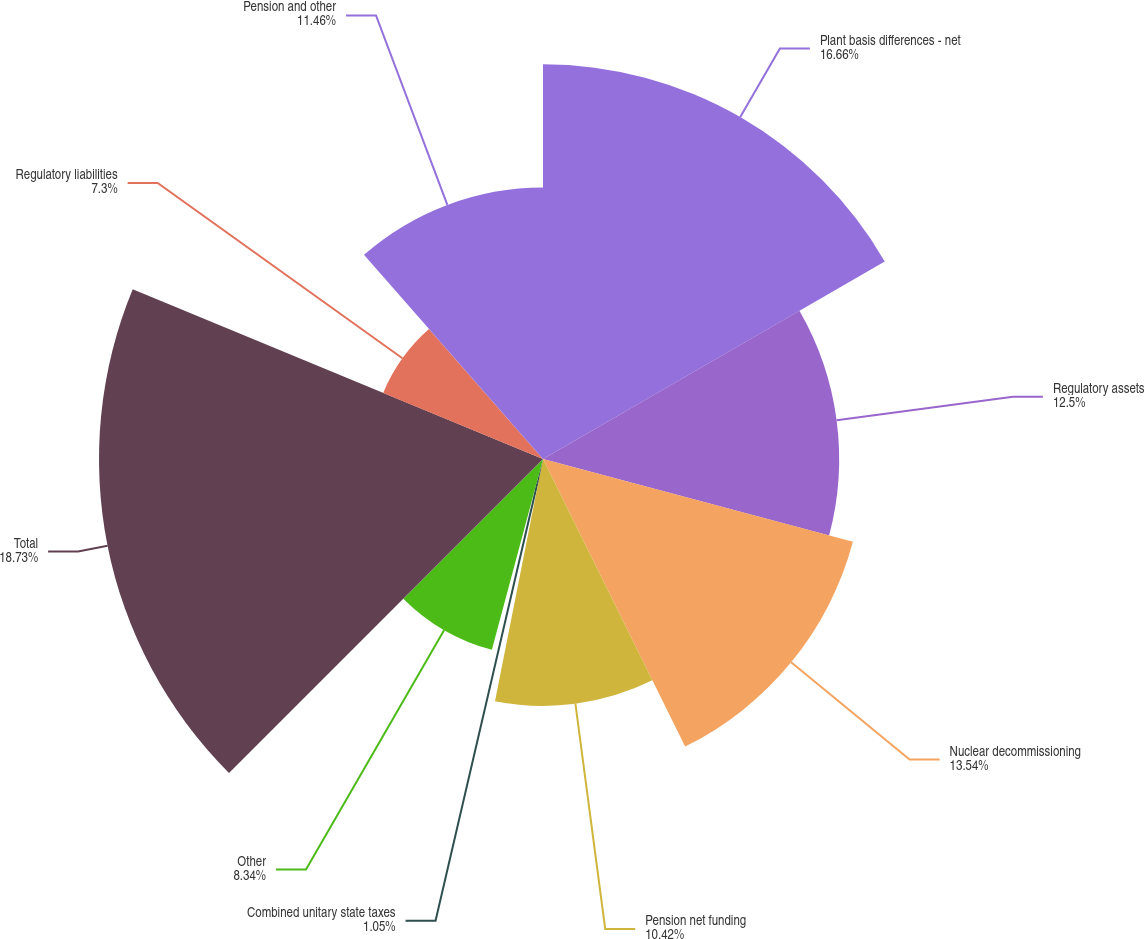Convert chart to OTSL. <chart><loc_0><loc_0><loc_500><loc_500><pie_chart><fcel>Plant basis differences - net<fcel>Regulatory assets<fcel>Nuclear decommissioning<fcel>Pension net funding<fcel>Combined unitary state taxes<fcel>Other<fcel>Total<fcel>Regulatory liabilities<fcel>Pension and other<nl><fcel>16.66%<fcel>12.5%<fcel>13.54%<fcel>10.42%<fcel>1.05%<fcel>8.34%<fcel>18.74%<fcel>7.3%<fcel>11.46%<nl></chart> 